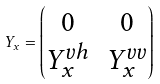Convert formula to latex. <formula><loc_0><loc_0><loc_500><loc_500>Y _ { x } = \begin{pmatrix} 0 & 0 \\ Y ^ { v h } _ { x } & Y ^ { v v } _ { x } \end{pmatrix}</formula> 